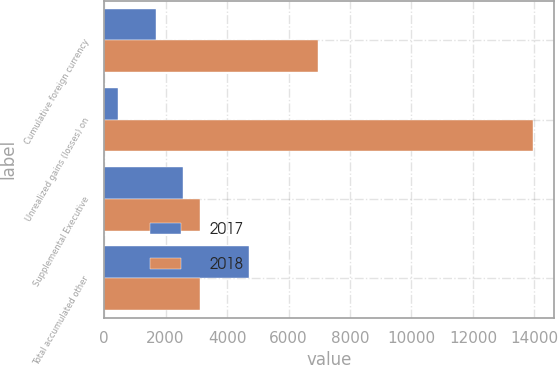Convert chart. <chart><loc_0><loc_0><loc_500><loc_500><stacked_bar_chart><ecel><fcel>Cumulative foreign currency<fcel>Unrealized gains (losses) on<fcel>Supplemental Executive<fcel>Total accumulated other<nl><fcel>2017<fcel>1683<fcel>467<fcel>2558<fcel>4708<nl><fcel>2018<fcel>6955<fcel>13950<fcel>3119<fcel>3119<nl></chart> 